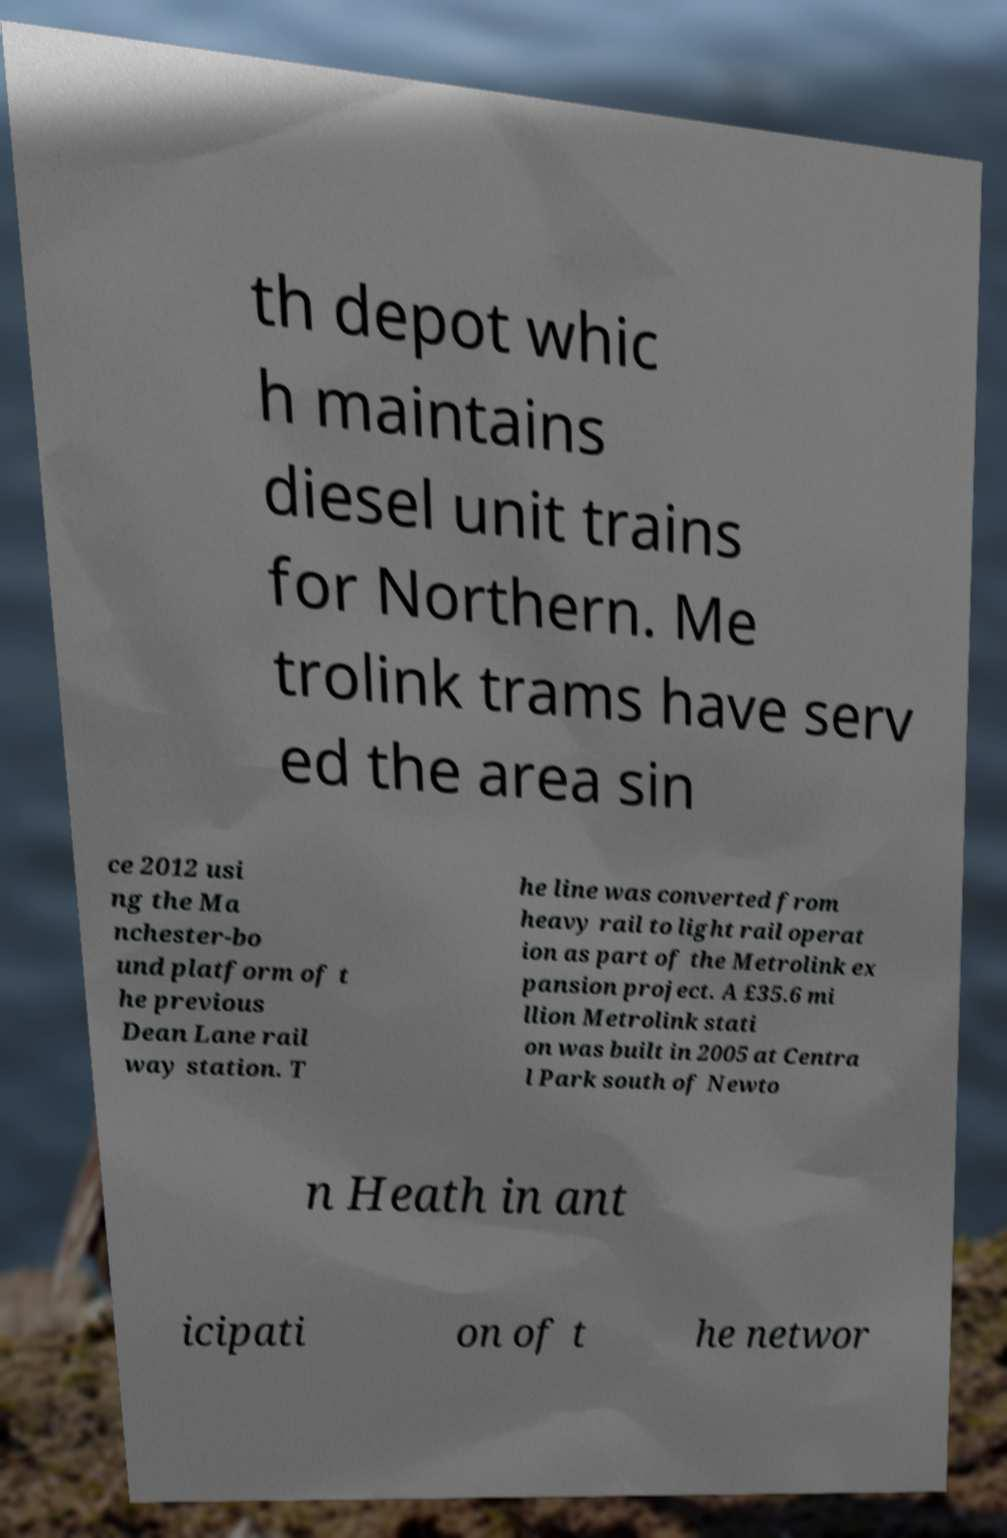What messages or text are displayed in this image? I need them in a readable, typed format. th depot whic h maintains diesel unit trains for Northern. Me trolink trams have serv ed the area sin ce 2012 usi ng the Ma nchester-bo und platform of t he previous Dean Lane rail way station. T he line was converted from heavy rail to light rail operat ion as part of the Metrolink ex pansion project. A £35.6 mi llion Metrolink stati on was built in 2005 at Centra l Park south of Newto n Heath in ant icipati on of t he networ 